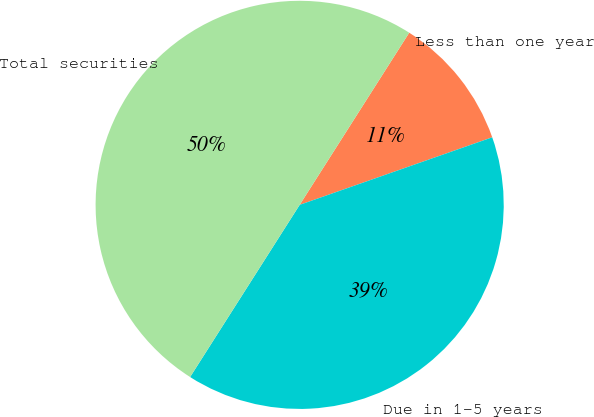Convert chart. <chart><loc_0><loc_0><loc_500><loc_500><pie_chart><fcel>Less than one year<fcel>Due in 1-5 years<fcel>Total securities<nl><fcel>10.61%<fcel>39.39%<fcel>50.0%<nl></chart> 